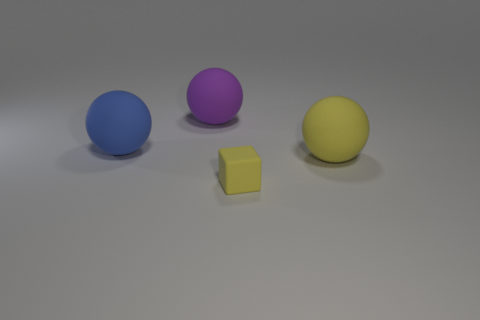Add 2 yellow rubber objects. How many objects exist? 6 Subtract all blocks. How many objects are left? 3 Subtract 1 blocks. How many blocks are left? 0 Subtract all yellow spheres. How many spheres are left? 2 Add 4 big yellow matte spheres. How many big yellow matte spheres are left? 5 Add 1 small yellow rubber blocks. How many small yellow rubber blocks exist? 2 Subtract 1 yellow balls. How many objects are left? 3 Subtract all blue spheres. Subtract all blue cylinders. How many spheres are left? 2 Subtract all yellow balls. How many blue cubes are left? 0 Subtract all brown cubes. Subtract all large balls. How many objects are left? 1 